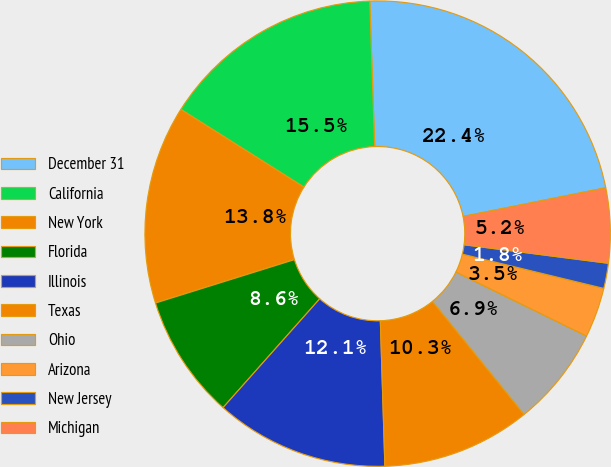Convert chart to OTSL. <chart><loc_0><loc_0><loc_500><loc_500><pie_chart><fcel>December 31<fcel>California<fcel>New York<fcel>Florida<fcel>Illinois<fcel>Texas<fcel>Ohio<fcel>Arizona<fcel>New Jersey<fcel>Michigan<nl><fcel>22.38%<fcel>15.5%<fcel>13.78%<fcel>8.62%<fcel>12.06%<fcel>10.34%<fcel>6.91%<fcel>3.47%<fcel>1.75%<fcel>5.19%<nl></chart> 